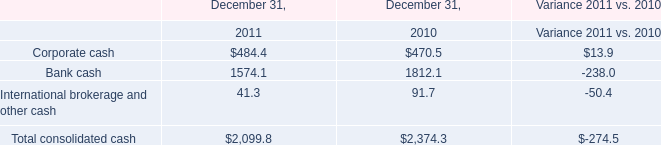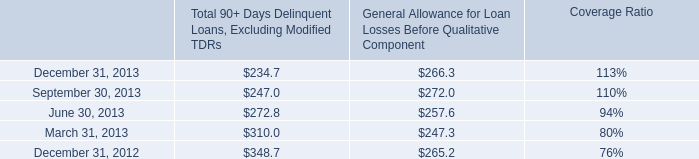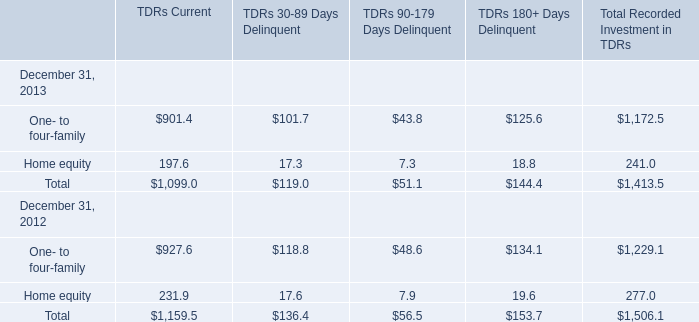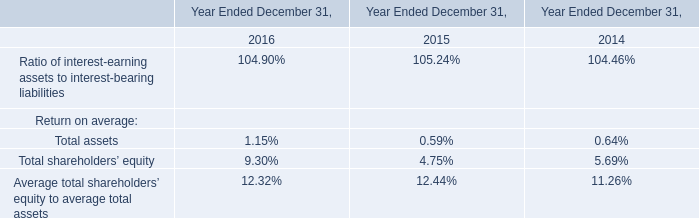Which year is Home equity for TDRs Current greater than 200 ? 
Answer: 2012. 